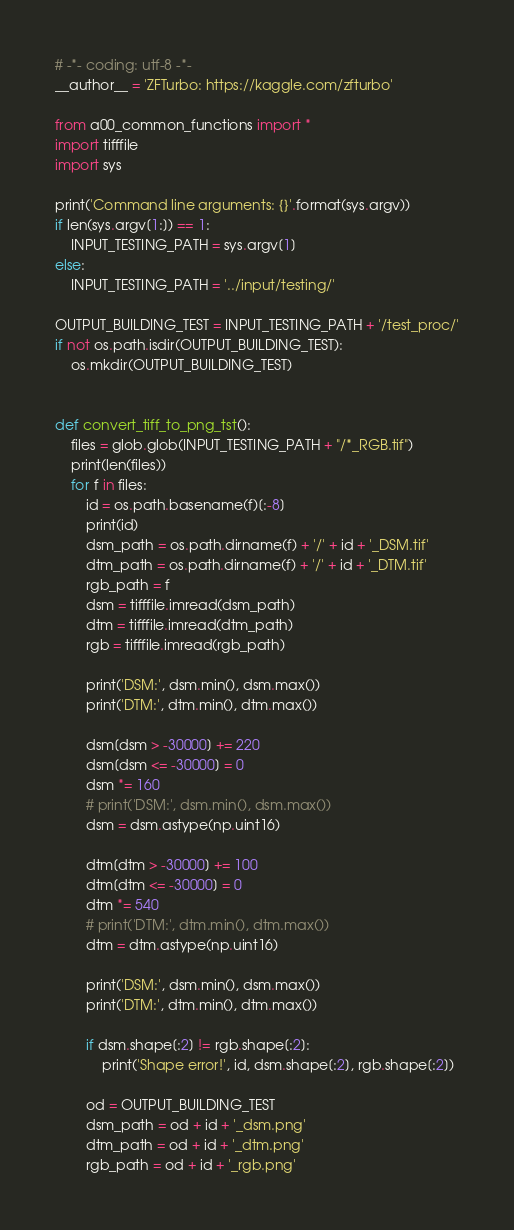<code> <loc_0><loc_0><loc_500><loc_500><_Python_># -*- coding: utf-8 -*-
__author__ = 'ZFTurbo: https://kaggle.com/zfturbo'

from a00_common_functions import *
import tifffile
import sys

print('Command line arguments: {}'.format(sys.argv))
if len(sys.argv[1:]) == 1:
    INPUT_TESTING_PATH = sys.argv[1]
else:
    INPUT_TESTING_PATH = '../input/testing/'

OUTPUT_BUILDING_TEST = INPUT_TESTING_PATH + '/test_proc/'
if not os.path.isdir(OUTPUT_BUILDING_TEST):
    os.mkdir(OUTPUT_BUILDING_TEST)


def convert_tiff_to_png_tst():
    files = glob.glob(INPUT_TESTING_PATH + "/*_RGB.tif")
    print(len(files))
    for f in files:
        id = os.path.basename(f)[:-8]
        print(id)
        dsm_path = os.path.dirname(f) + '/' + id + '_DSM.tif'
        dtm_path = os.path.dirname(f) + '/' + id + '_DTM.tif'
        rgb_path = f
        dsm = tifffile.imread(dsm_path)
        dtm = tifffile.imread(dtm_path)
        rgb = tifffile.imread(rgb_path)

        print('DSM:', dsm.min(), dsm.max())
        print('DTM:', dtm.min(), dtm.max())

        dsm[dsm > -30000] += 220
        dsm[dsm <= -30000] = 0
        dsm *= 160
        # print('DSM:', dsm.min(), dsm.max())
        dsm = dsm.astype(np.uint16)

        dtm[dtm > -30000] += 100
        dtm[dtm <= -30000] = 0
        dtm *= 540
        # print('DTM:', dtm.min(), dtm.max())
        dtm = dtm.astype(np.uint16)

        print('DSM:', dsm.min(), dsm.max())
        print('DTM:', dtm.min(), dtm.max())

        if dsm.shape[:2] != rgb.shape[:2]:
            print('Shape error!', id, dsm.shape[:2], rgb.shape[:2])

        od = OUTPUT_BUILDING_TEST
        dsm_path = od + id + '_dsm.png'
        dtm_path = od + id + '_dtm.png'
        rgb_path = od + id + '_rgb.png'</code> 